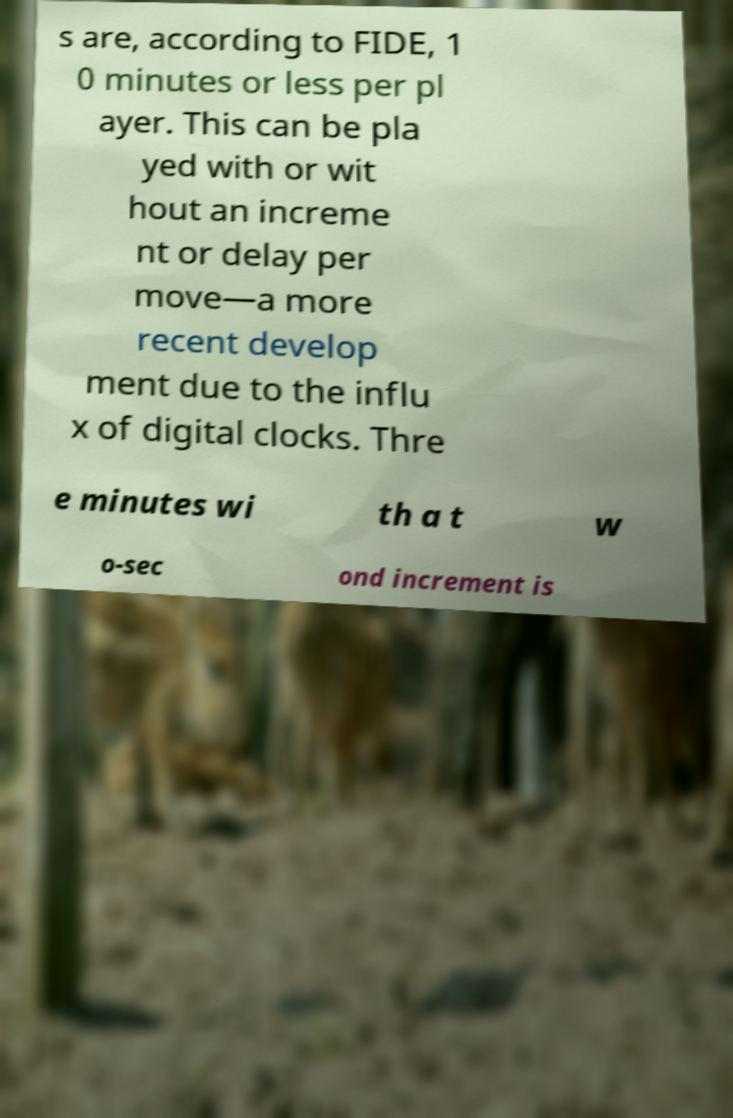Can you accurately transcribe the text from the provided image for me? s are, according to FIDE, 1 0 minutes or less per pl ayer. This can be pla yed with or wit hout an increme nt or delay per move—a more recent develop ment due to the influ x of digital clocks. Thre e minutes wi th a t w o-sec ond increment is 